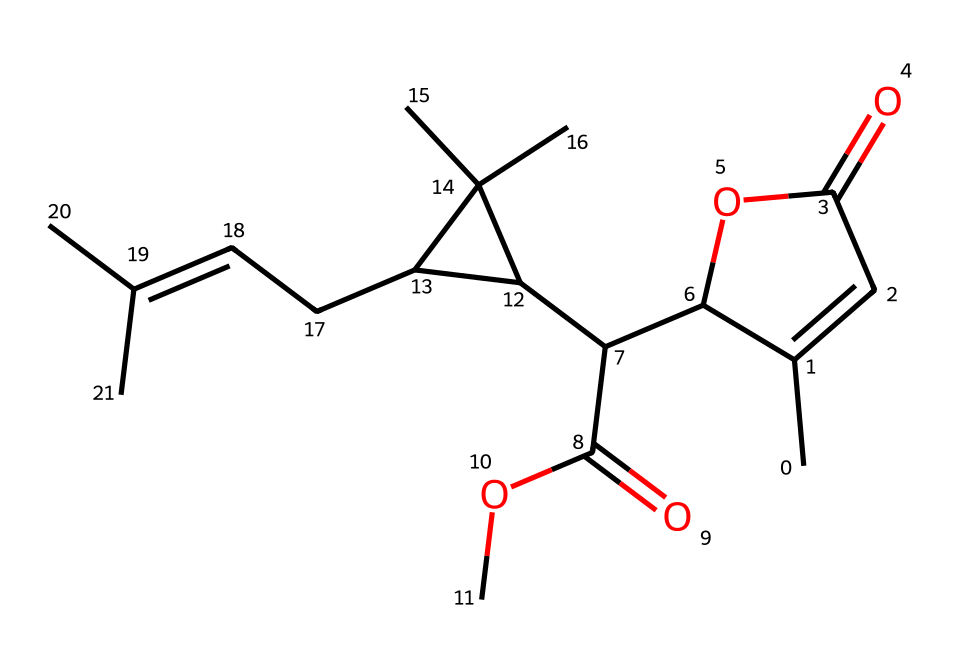What is the molecular formula of pyrethrin? To determine the molecular formula, count the carbon (C), hydrogen (H), and oxygen (O) atoms in the SMILES representation. The structure shows 21 carbons, 28 hydrogens, and 5 oxygens. Thus, the molecular formula is C21H28O5.
Answer: C21H28O5 How many rings are present in the chemical structure of pyrethrin? By examining the SMILES, identify the segments that indicate ring structures (the set of C=C and C-C bonds contributing to closed loops). There are two distinct cyclic structures in pyrethrin.
Answer: 2 Which functional groups are present in pyrethrin? Analyze the functional groups in the molecule. The SMILES indicates the presence of esters (–COO–) and a ketone (–C=O). Therefore, the functional groups are ester and ketone.
Answer: ester, ketone What type of chemical structure is pyrethrin classified as? Look at the overall structure shown in the SMILES and identify major characteristics that categorize it. Pyrethrin is a natural insecticide and is primarily recognized as a pyrethroid.
Answer: pyrethroid What property of pyrethrin contributes to its effectiveness as an insecticide? Consider the chemical structure features that have insecticidal properties; such as stability and ability to disrupt insect nervous systems. The presence of specific reactive bonds within the molecule, particularly the esters and cyclic structures, influences its activity.
Answer: reactive bonds How many oxygen atoms are in the structure of pyrethrin? Simply tally the oxygen atoms represented in the SMILES, which indicates the number of oxygen present. There are 5 oxygen atoms noted in the chemical structure.
Answer: 5 What is the significance of the double bonds in pyrethrin's structure? Assess the role of double bonds, as they generally contribute to the reactivity of the molecule and its interaction with target organisms. The double bonds in the ring structures enhance the molecule’s ability to disrupt insect nerve function.
Answer: reactivity 